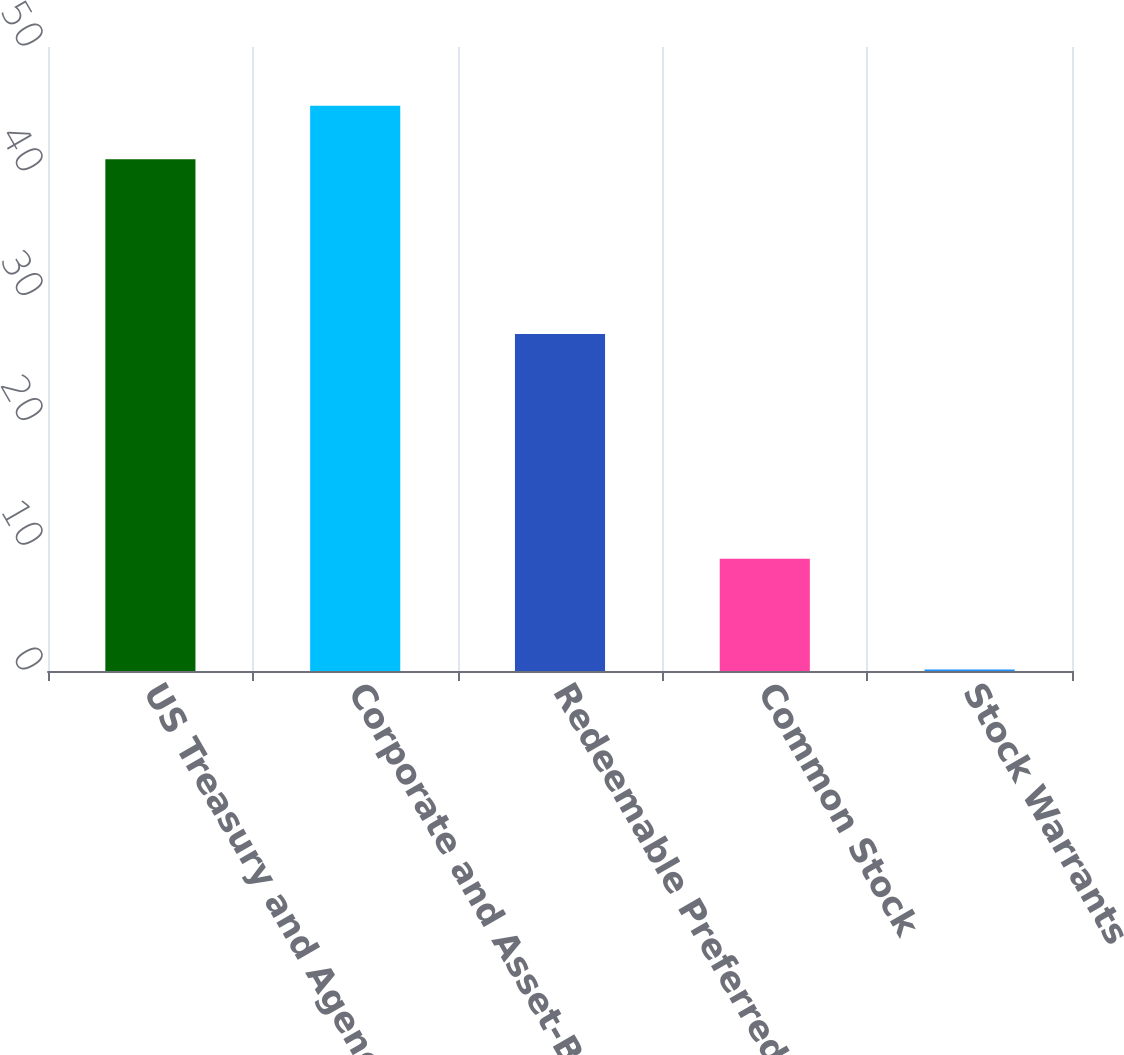Convert chart to OTSL. <chart><loc_0><loc_0><loc_500><loc_500><bar_chart><fcel>US Treasury and Agency<fcel>Corporate and Asset-Backed (a)<fcel>Redeemable Preferred Stock<fcel>Common Stock<fcel>Stock Warrants<nl><fcel>41<fcel>45.29<fcel>27<fcel>9<fcel>0.12<nl></chart> 